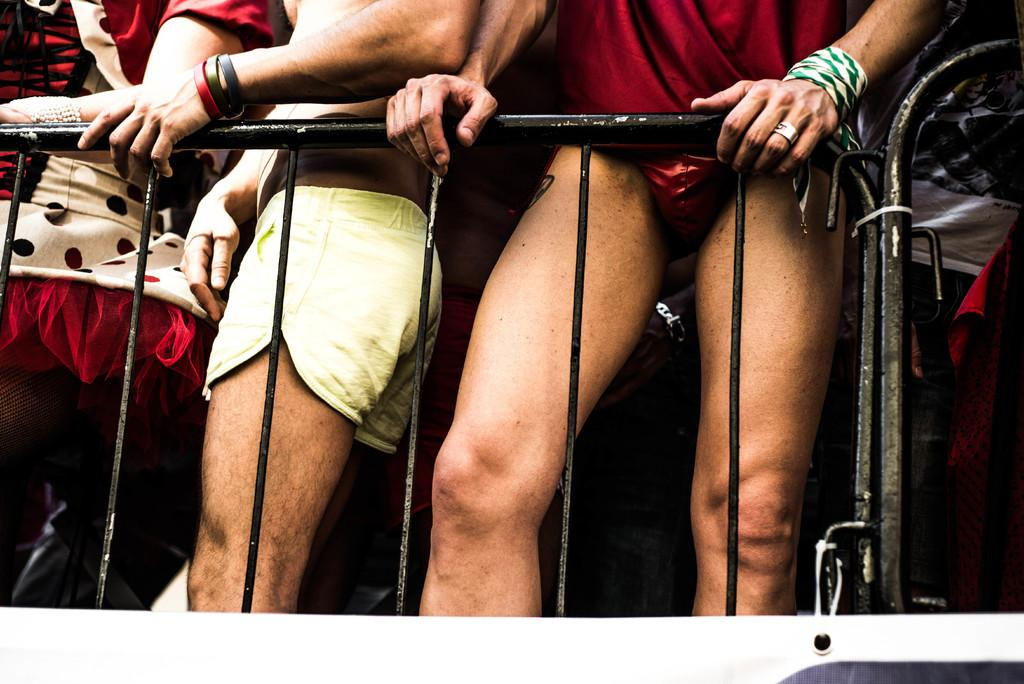Where was the image taken? The image is taken outdoors. How many persons can be seen in the image? There are a few persons standing in the image. What surface are the persons standing on? The persons are standing on the floor. What feature is present in the image that might be used for support or safety? There is a railing in the image. What type of pet can be seen playing with a hose in the image? There is no pet or hose present in the image; it features a few persons standing outdoors with a railing. 